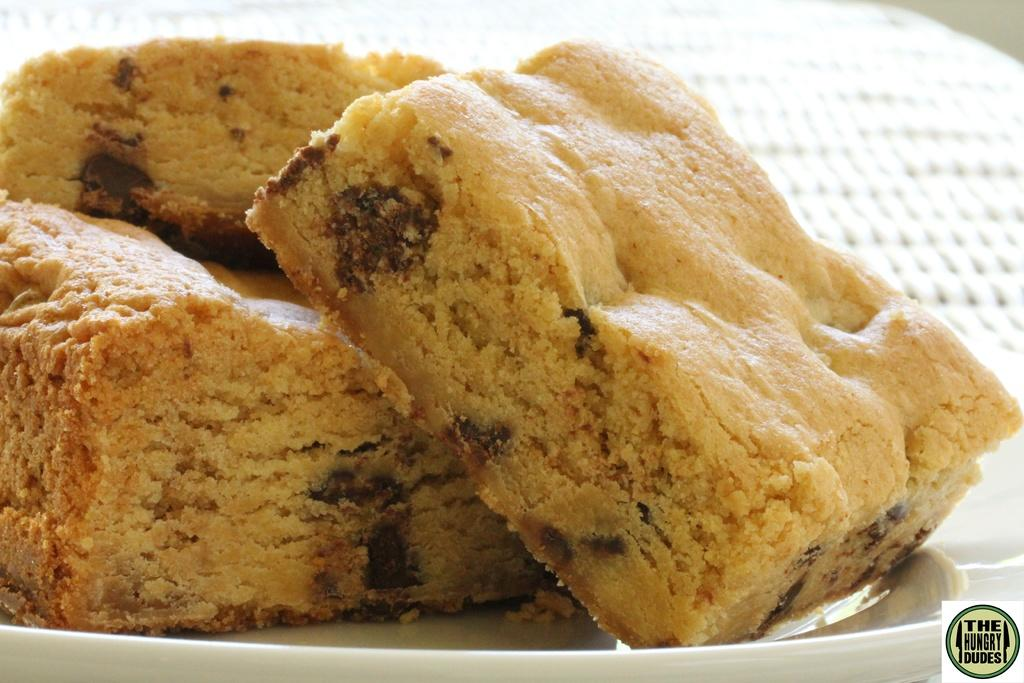What is present on the plate in the image? There are food items in a plate in the image. Can you describe any additional details about the image? Yes, there is a logo visible in the bottom right of the image. What is the belief of the cherries in the image? There are no cherries present in the image, so it is not possible to determine their beliefs. 